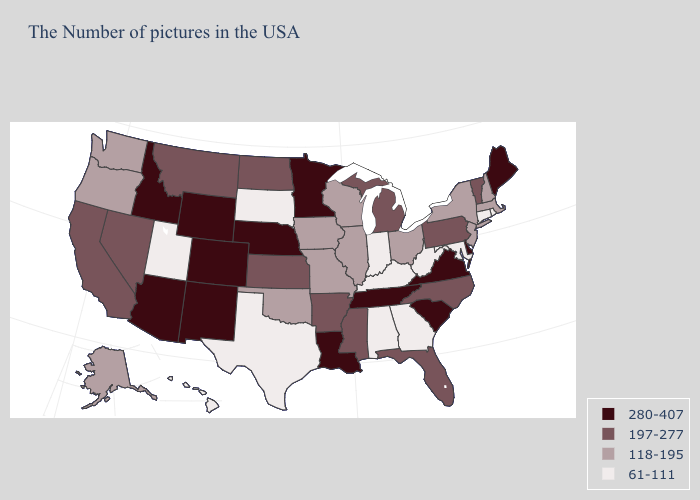Name the states that have a value in the range 118-195?
Answer briefly. Massachusetts, New Hampshire, New York, New Jersey, Ohio, Wisconsin, Illinois, Missouri, Iowa, Oklahoma, Washington, Oregon, Alaska. What is the value of Nebraska?
Quick response, please. 280-407. Does South Dakota have the lowest value in the USA?
Be succinct. Yes. Name the states that have a value in the range 197-277?
Answer briefly. Vermont, Pennsylvania, North Carolina, Florida, Michigan, Mississippi, Arkansas, Kansas, North Dakota, Montana, Nevada, California. Does the first symbol in the legend represent the smallest category?
Write a very short answer. No. What is the value of Arizona?
Give a very brief answer. 280-407. Name the states that have a value in the range 197-277?
Concise answer only. Vermont, Pennsylvania, North Carolina, Florida, Michigan, Mississippi, Arkansas, Kansas, North Dakota, Montana, Nevada, California. What is the highest value in the USA?
Short answer required. 280-407. What is the lowest value in the West?
Keep it brief. 61-111. Name the states that have a value in the range 197-277?
Be succinct. Vermont, Pennsylvania, North Carolina, Florida, Michigan, Mississippi, Arkansas, Kansas, North Dakota, Montana, Nevada, California. Name the states that have a value in the range 61-111?
Be succinct. Rhode Island, Connecticut, Maryland, West Virginia, Georgia, Kentucky, Indiana, Alabama, Texas, South Dakota, Utah, Hawaii. What is the lowest value in states that border Kansas?
Be succinct. 118-195. Name the states that have a value in the range 61-111?
Give a very brief answer. Rhode Island, Connecticut, Maryland, West Virginia, Georgia, Kentucky, Indiana, Alabama, Texas, South Dakota, Utah, Hawaii. What is the value of Alaska?
Give a very brief answer. 118-195. 